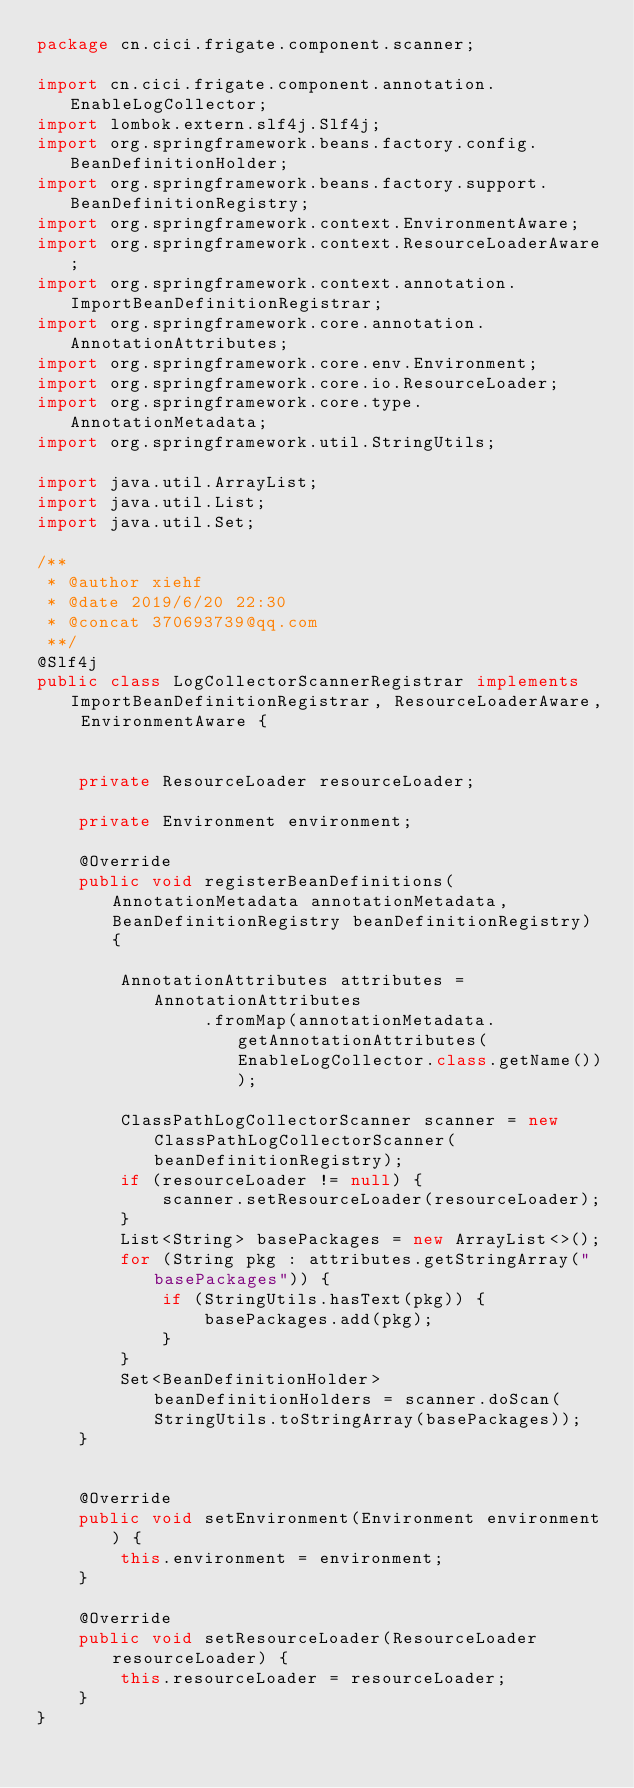<code> <loc_0><loc_0><loc_500><loc_500><_Java_>package cn.cici.frigate.component.scanner;

import cn.cici.frigate.component.annotation.EnableLogCollector;
import lombok.extern.slf4j.Slf4j;
import org.springframework.beans.factory.config.BeanDefinitionHolder;
import org.springframework.beans.factory.support.BeanDefinitionRegistry;
import org.springframework.context.EnvironmentAware;
import org.springframework.context.ResourceLoaderAware;
import org.springframework.context.annotation.ImportBeanDefinitionRegistrar;
import org.springframework.core.annotation.AnnotationAttributes;
import org.springframework.core.env.Environment;
import org.springframework.core.io.ResourceLoader;
import org.springframework.core.type.AnnotationMetadata;
import org.springframework.util.StringUtils;

import java.util.ArrayList;
import java.util.List;
import java.util.Set;

/**
 * @author xiehf
 * @date 2019/6/20 22:30
 * @concat 370693739@qq.com
 **/
@Slf4j
public class LogCollectorScannerRegistrar implements ImportBeanDefinitionRegistrar, ResourceLoaderAware, EnvironmentAware {


    private ResourceLoader resourceLoader;

    private Environment environment;

    @Override
    public void registerBeanDefinitions(AnnotationMetadata annotationMetadata, BeanDefinitionRegistry beanDefinitionRegistry) {

        AnnotationAttributes attributes = AnnotationAttributes
                .fromMap(annotationMetadata.getAnnotationAttributes(EnableLogCollector.class.getName()));

        ClassPathLogCollectorScanner scanner = new ClassPathLogCollectorScanner(beanDefinitionRegistry);
        if (resourceLoader != null) {
            scanner.setResourceLoader(resourceLoader);
        }
        List<String> basePackages = new ArrayList<>();
        for (String pkg : attributes.getStringArray("basePackages")) {
            if (StringUtils.hasText(pkg)) {
                basePackages.add(pkg);
            }
        }
        Set<BeanDefinitionHolder> beanDefinitionHolders = scanner.doScan(StringUtils.toStringArray(basePackages));
    }


    @Override
    public void setEnvironment(Environment environment) {
        this.environment = environment;
    }

    @Override
    public void setResourceLoader(ResourceLoader resourceLoader) {
        this.resourceLoader = resourceLoader;
    }
}
</code> 